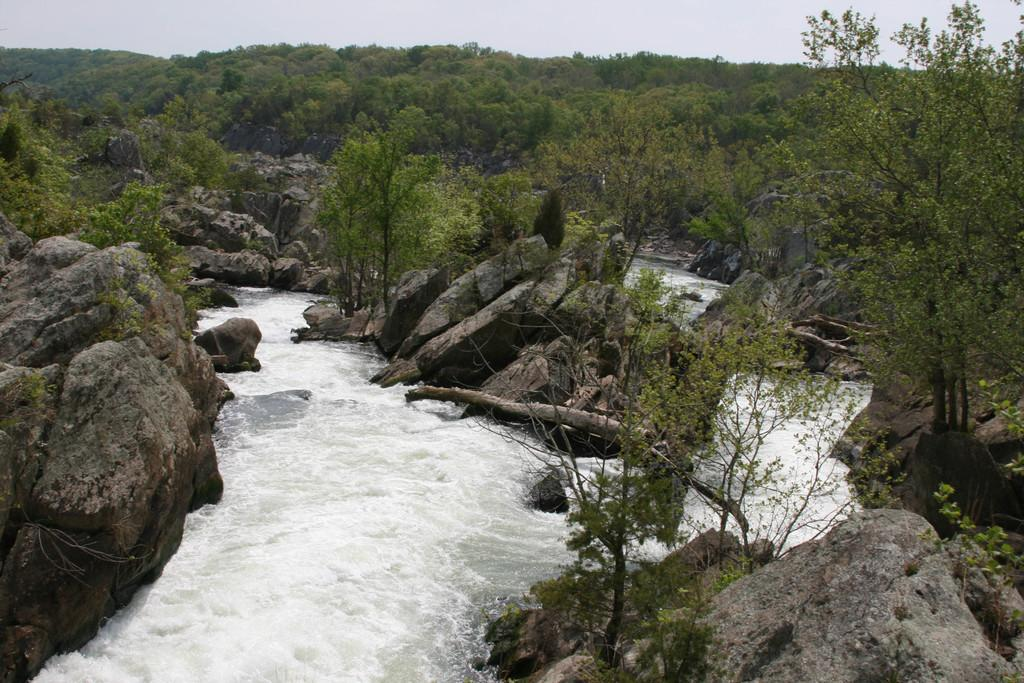What type of body of water is present in the image? There is a lake in the image. What is the state of the lake in the image? The lake appears to be flowing. What other natural elements can be seen in the image? There are big stones and a forest visible in the image. What is visible in the background of the image? The sky is visible in the background of the image. How many frogs are sitting on the partner's sack in the image? There are no frogs or partners present in the image; it features a flowing lake, big stones, a forest, and the sky. 